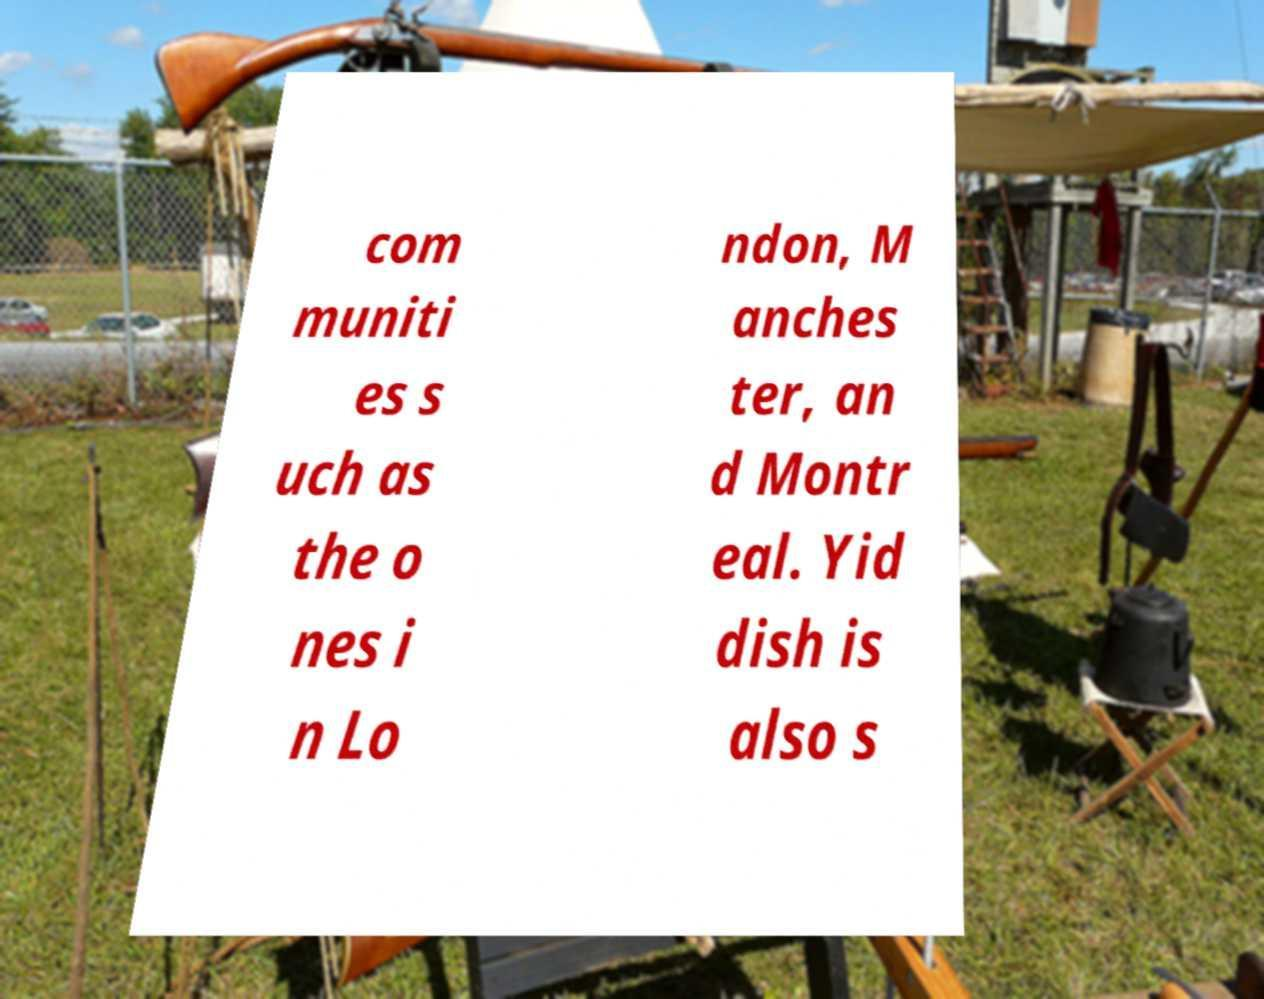Can you accurately transcribe the text from the provided image for me? com muniti es s uch as the o nes i n Lo ndon, M anches ter, an d Montr eal. Yid dish is also s 